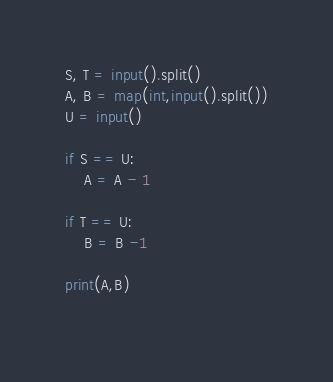Convert code to text. <code><loc_0><loc_0><loc_500><loc_500><_Python_>S, T = input().split()
A, B = map(int,input().split())
U = input()

if S == U:
    A = A - 1
    
if T == U:
    B = B -1
    
print(A,B)
    
</code> 